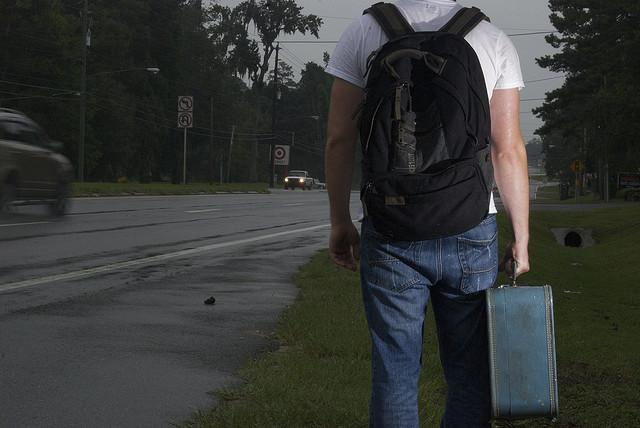What does the backpacking man hope for? ride 